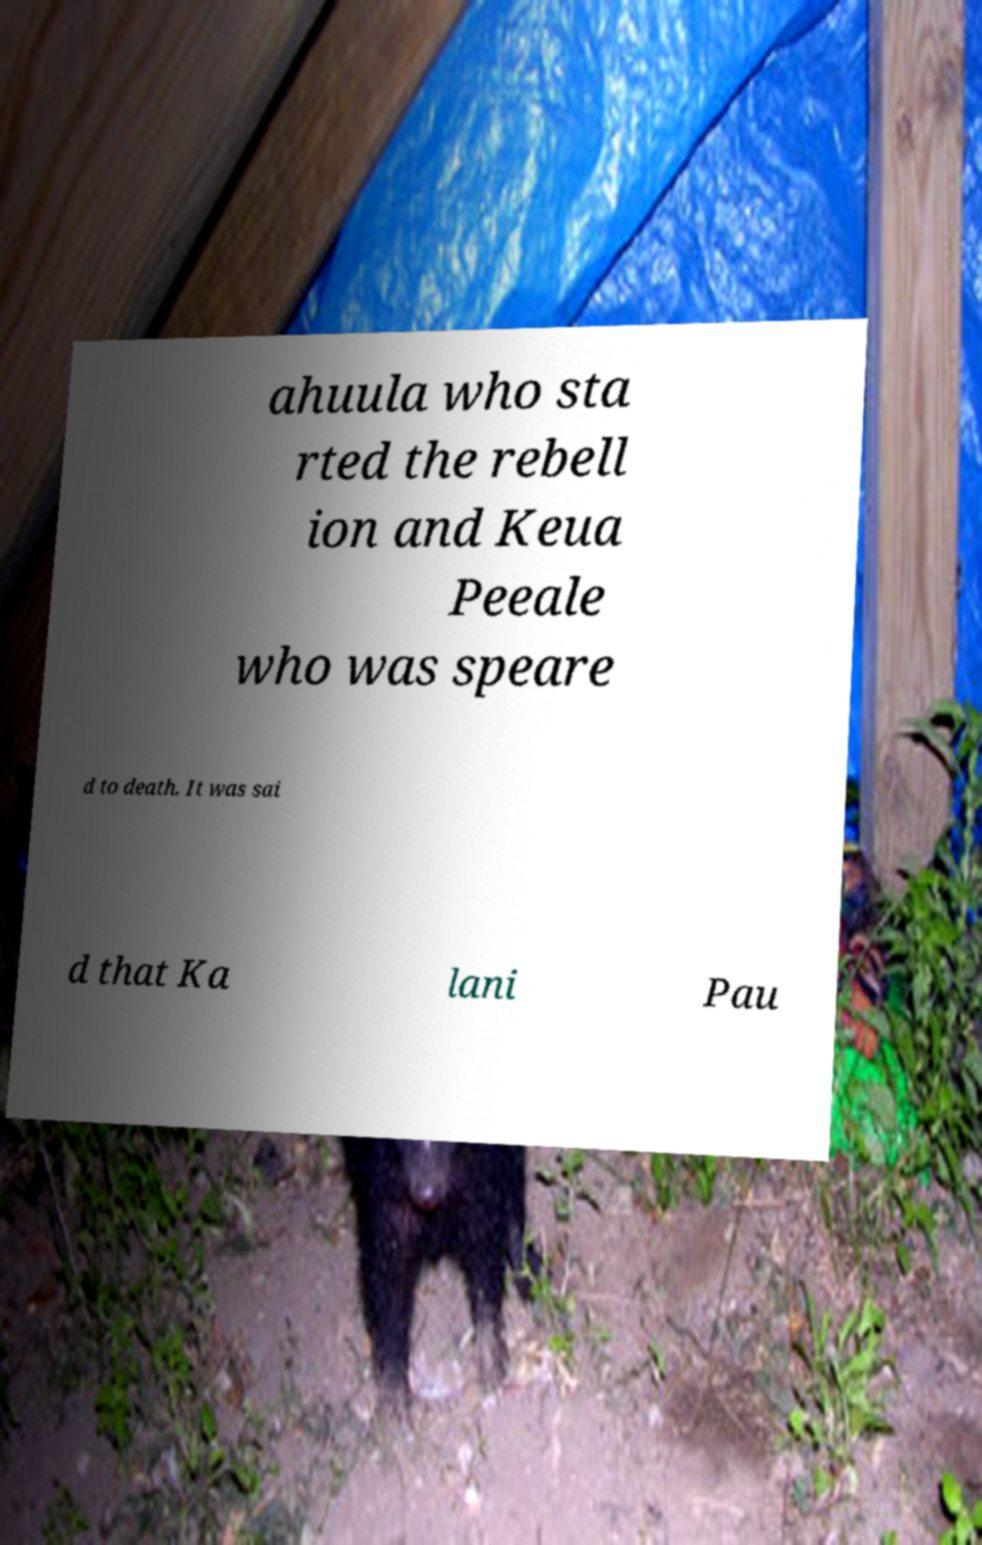Could you assist in decoding the text presented in this image and type it out clearly? ahuula who sta rted the rebell ion and Keua Peeale who was speare d to death. It was sai d that Ka lani Pau 